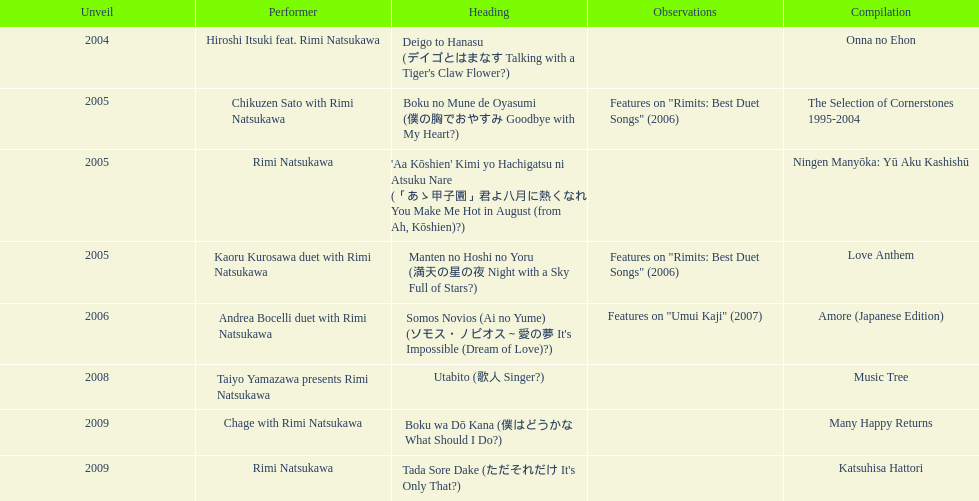What song was this artist on after utabito? Boku wa Dō Kana. 